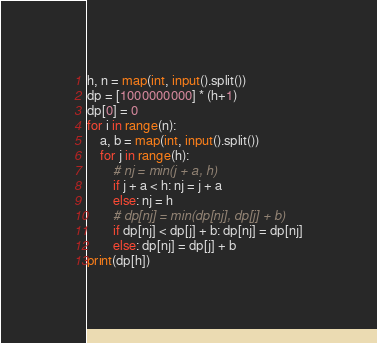Convert code to text. <code><loc_0><loc_0><loc_500><loc_500><_Python_>h, n = map(int, input().split())
dp = [1000000000] * (h+1)
dp[0] = 0
for i in range(n):
    a, b = map(int, input().split())
    for j in range(h):
        # nj = min(j + a, h)
        if j + a < h: nj = j + a
        else: nj = h
        # dp[nj] = min(dp[nj], dp[j] + b)
        if dp[nj] < dp[j] + b: dp[nj] = dp[nj]
        else: dp[nj] = dp[j] + b
print(dp[h])</code> 